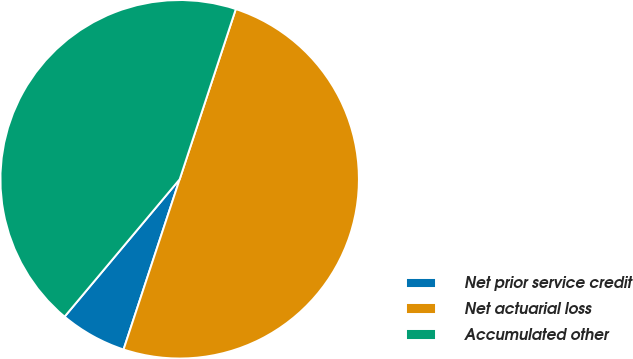<chart> <loc_0><loc_0><loc_500><loc_500><pie_chart><fcel>Net prior service credit<fcel>Net actuarial loss<fcel>Accumulated other<nl><fcel>6.03%<fcel>50.0%<fcel>43.97%<nl></chart> 